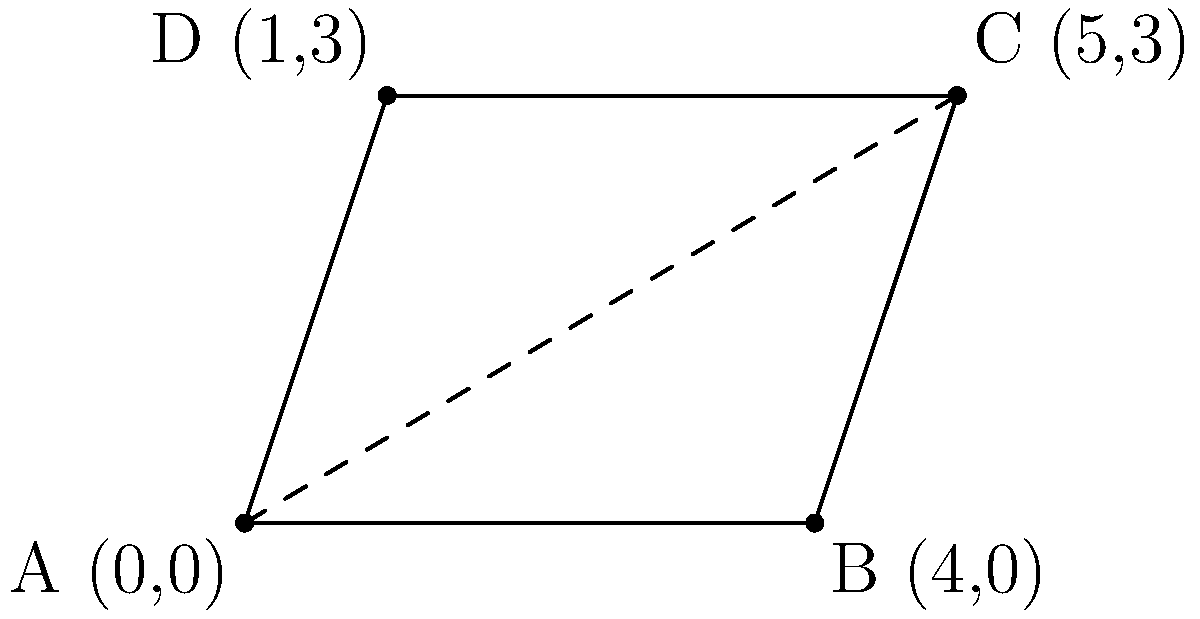During a Jeonnam Dragons match, four players' positions form a parallelogram on the field. Player A is at (0,0), B at (4,0), C at (5,3), and D at (1,3). Calculate the area of the parallelogram formed by these players' positions. To find the area of the parallelogram, we can follow these steps:

1) The area of a parallelogram is given by the formula:
   $$Area = base \times height$$

2) We can choose either AB or DC as the base. Let's use AB as the base.
   The length of AB is: $$\sqrt{(4-0)^2 + (0-0)^2} = 4$$

3) To find the height, we need to calculate the perpendicular distance from point D to line AB.

4) We can use the formula for the distance of a point (x,y) from a line Ax + By + C = 0:
   $$Distance = \frac{|Ax + By + C|}{\sqrt{A^2 + B^2}}$$

5) The equation of line AB is y = 0, which can be written as 0x + 1y + 0 = 0

6) Substituting the coordinates of D (1,3) and the coefficients of the line equation:
   $$Height = \frac{|0(1) + 1(3) + 0|}{\sqrt{0^2 + 1^2}} = \frac{3}{1} = 3$$

7) Now we can calculate the area:
   $$Area = base \times height = 4 \times 3 = 12$$

Therefore, the area of the parallelogram is 12 square units.
Answer: 12 square units 